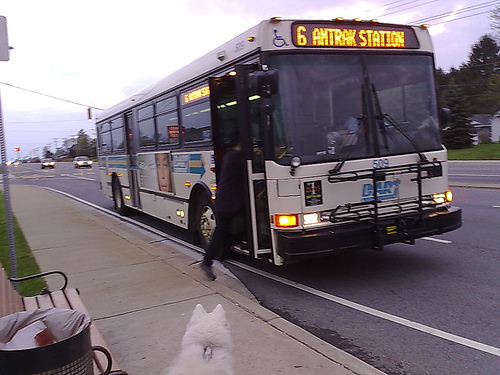What can you tell me about the surroundings where the bus is located? The bus is located on a busy street lined with essential urban infrastructure, including street lamps, pedestrian sidewalks, and road markings catering to multiple modes of transport. The looming clouds suggest an overcast weather condition, adding a dim backdrop to this everyday urban scene. 